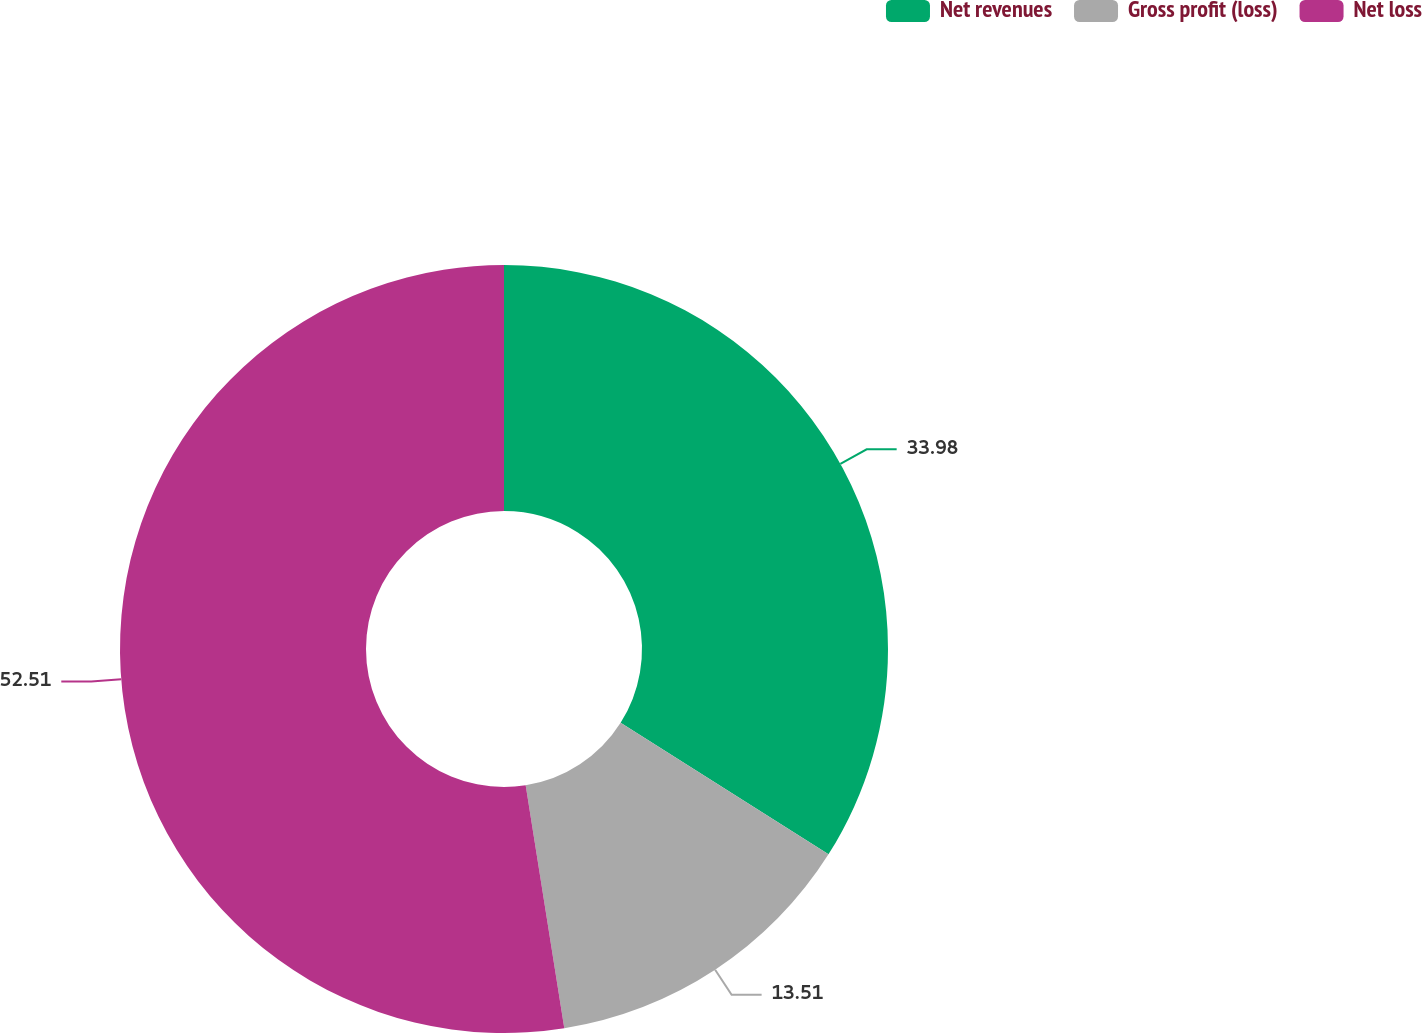<chart> <loc_0><loc_0><loc_500><loc_500><pie_chart><fcel>Net revenues<fcel>Gross profit (loss)<fcel>Net loss<nl><fcel>33.98%<fcel>13.51%<fcel>52.51%<nl></chart> 